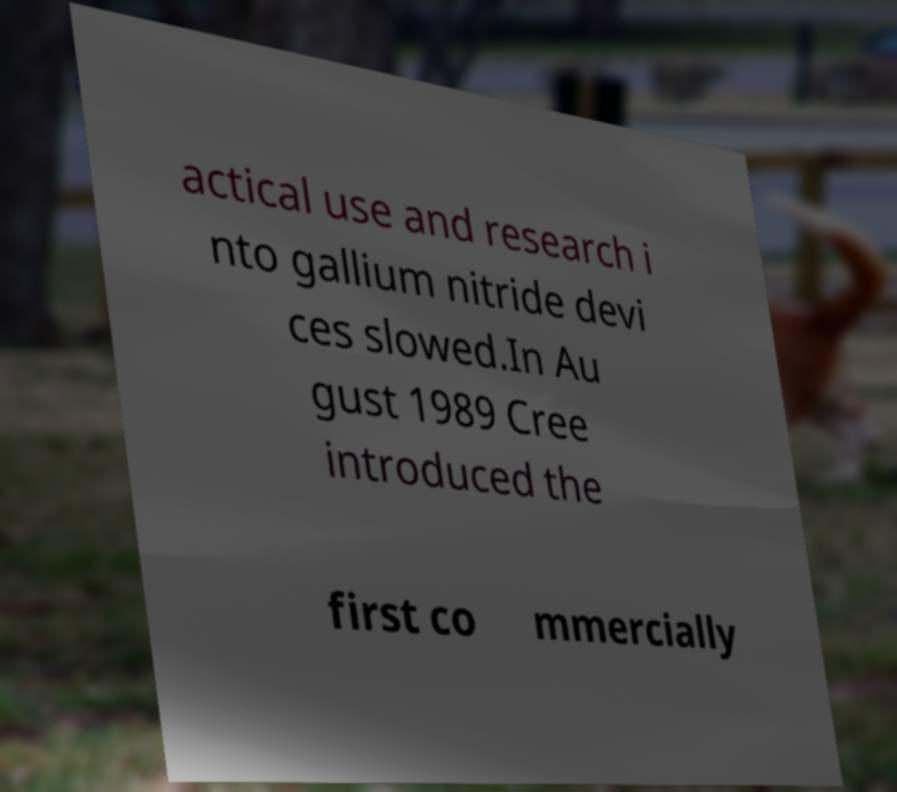There's text embedded in this image that I need extracted. Can you transcribe it verbatim? actical use and research i nto gallium nitride devi ces slowed.In Au gust 1989 Cree introduced the first co mmercially 